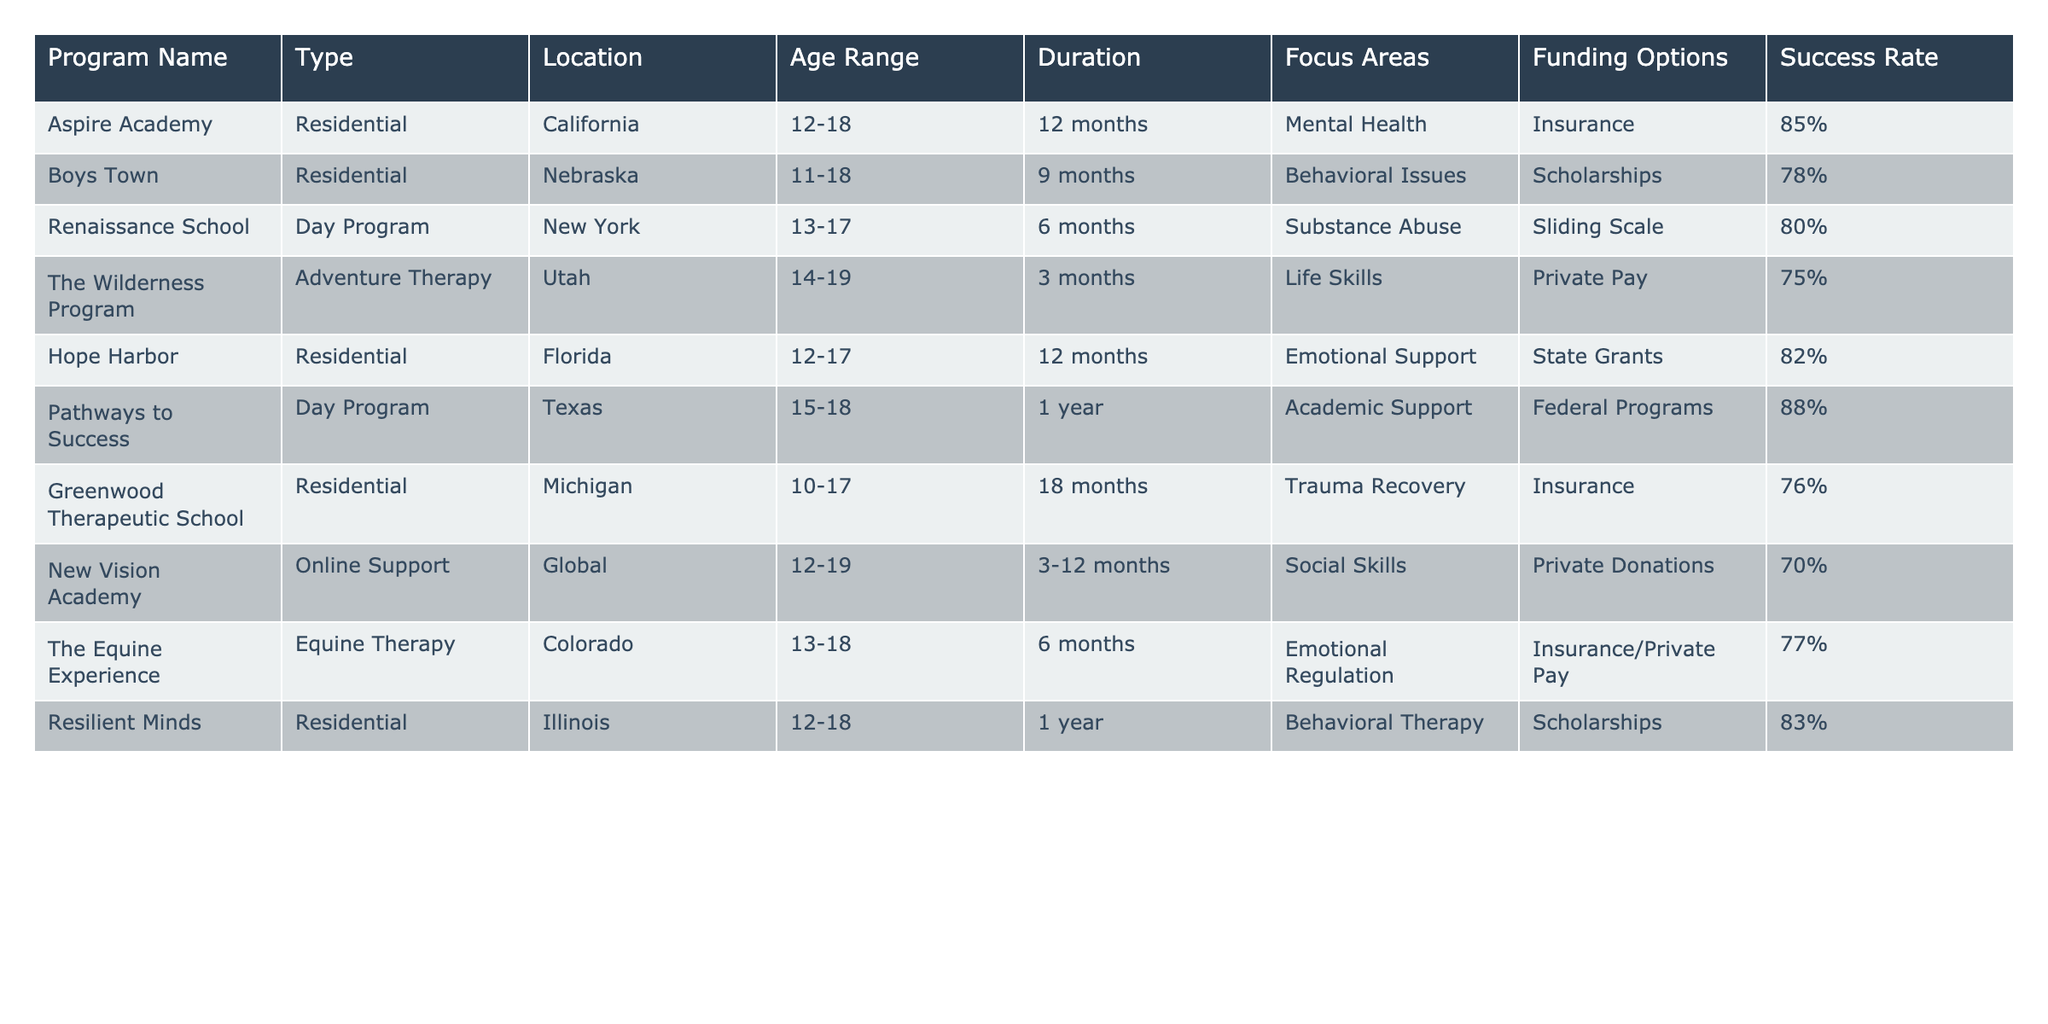What is the highest success rate among the programs listed? The success rates for each program are compared. Aspire Academy has a success rate of 85%, while Pathways to Success has the highest at 88%.
Answer: 88% Which program focuses specifically on Substance Abuse? Looking through the table, Renaissance School is the only program explicitly focusing on Substance Abuse.
Answer: Renaissance School What is the duration of the Boys Town program? The duration of the Boys Town program is specified in the table as 9 months.
Answer: 9 months Are there any programs with a success rate below 75%? The success rates of all programs listed are checked. The Wilderness Program has a success rate of 75%, hence no program has a success rate below this figure.
Answer: No What is the average success rate of all programs? The success rates of all programs are added together: (85 + 78 + 80 + 75 + 82 + 88 + 76 + 70 + 77 + 83) =  794. There are 10 programs, so the average is 794/10 = 79.4.
Answer: 79.4% Which state has the highest number of residential programs? The table is checked for residential programs. There are three residential programs in Florida, California, and Nebraska. Since California only has one, it does not exceed those in Florida and Illinois, which also have one.
Answer: Florida and Illinois (each have one) What age range does The Equine Experience accept? The age range for The Equine Experience is indicated in the table as 13-18.
Answer: 13-18 How many programs are located in Texas? The table is reviewed for locations; only one program, Pathways to Success, is located in Texas.
Answer: 1 Which program has the longest duration? The durations of all programs are compared, with Greenwood Therapeutic School's duration listed as 18 months, which is the longest.
Answer: 18 months What type of funding does Hope Harbor utilize? The table specifies the funding options for Hope Harbor as State Grants.
Answer: State Grants 